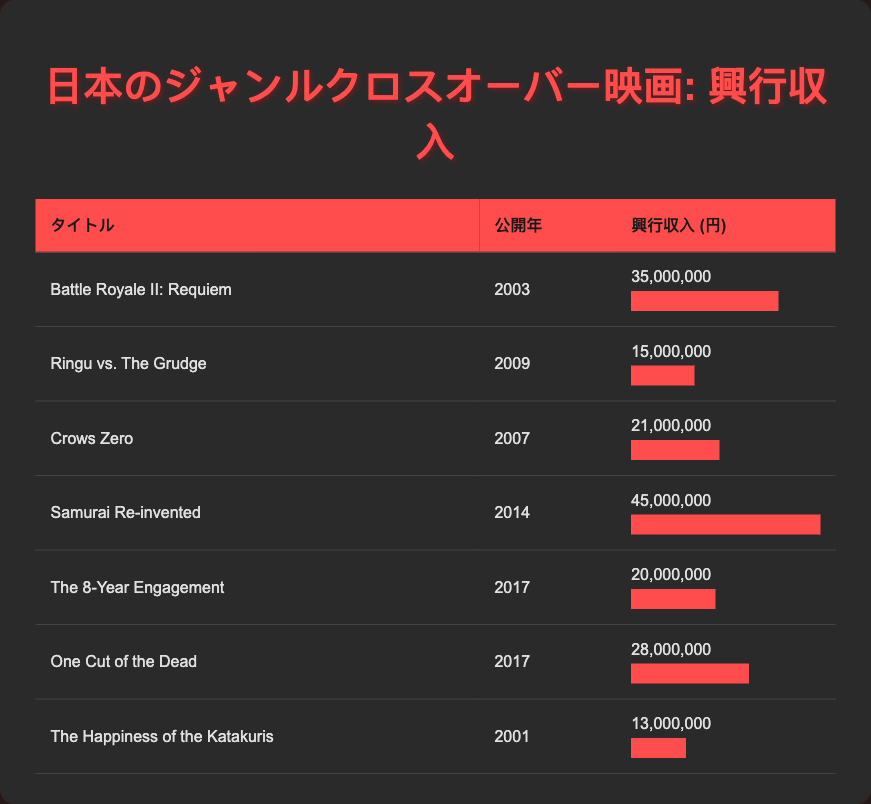What is the highest box office revenue among these films? The table lists box office revenues for each film. Looking through the list, "Samurai Re-invented" has the highest revenue at 45,000,000.
Answer: 45,000,000 Which film was released in 2007 and what was its box office revenue? From the table, there are two films from 2007: "Crows Zero" with a revenue of 21,000,000.
Answer: Crows Zero, 21,000,000 How many films have a box office revenue greater than 25,000,000? By examining the table, the films with revenues greater than 25,000,000 are "Battle Royale II: Requiem" (35,000,000), "Samurai Re-invented" (45,000,000), and "One Cut of the Dead" (28,000,000). This totals three films.
Answer: 3 What is the average box office revenue of the films released in 2017? The films released in 2017 are "The 8-Year Engagement" (20,000,000) and "One Cut of the Dead" (28,000,000). To find the average, sum the revenues: 20,000,000 + 28,000,000 = 48,000,000. Divide by the number of films: 48,000,000 / 2 = 24,000,000.
Answer: 24,000,000 Is "The Happiness of the Katakuris" the film with the least box office revenue? Checking the revenue of "The Happiness of the Katakuris," which is 13,000,000, we find other films have lower revenues. Therefore, the statement is false.
Answer: No 